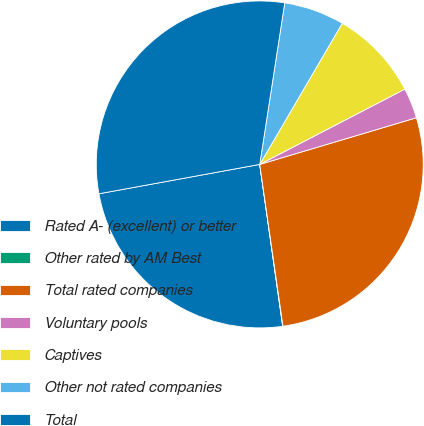Convert chart to OTSL. <chart><loc_0><loc_0><loc_500><loc_500><pie_chart><fcel>Rated A- (excellent) or better<fcel>Other rated by AM Best<fcel>Total rated companies<fcel>Voluntary pools<fcel>Captives<fcel>Other not rated companies<fcel>Total<nl><fcel>24.37%<fcel>0.03%<fcel>27.34%<fcel>3.01%<fcel>8.96%<fcel>5.98%<fcel>30.32%<nl></chart> 